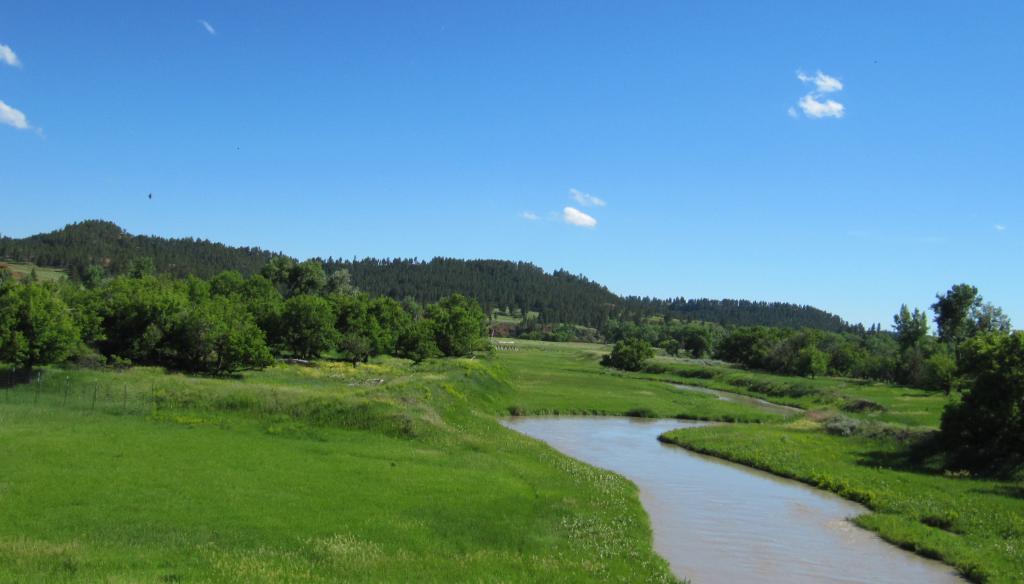Please provide a concise description of this image. Sky is in blue color. Here we can see water, grass and a number of trees. These are clouds. 